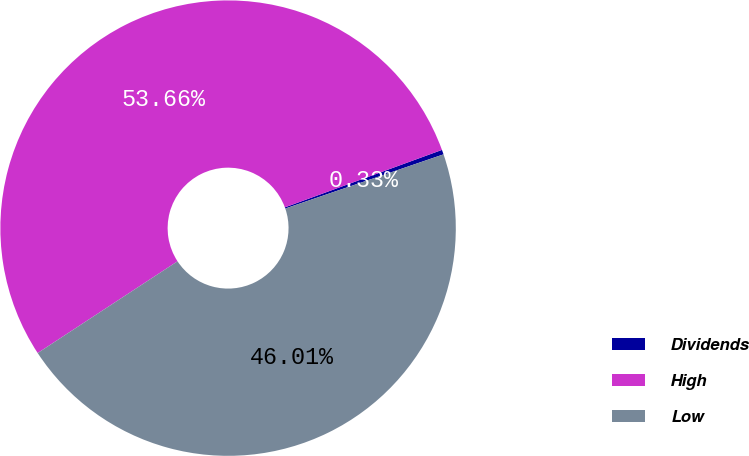<chart> <loc_0><loc_0><loc_500><loc_500><pie_chart><fcel>Dividends<fcel>High<fcel>Low<nl><fcel>0.33%<fcel>53.66%<fcel>46.01%<nl></chart> 